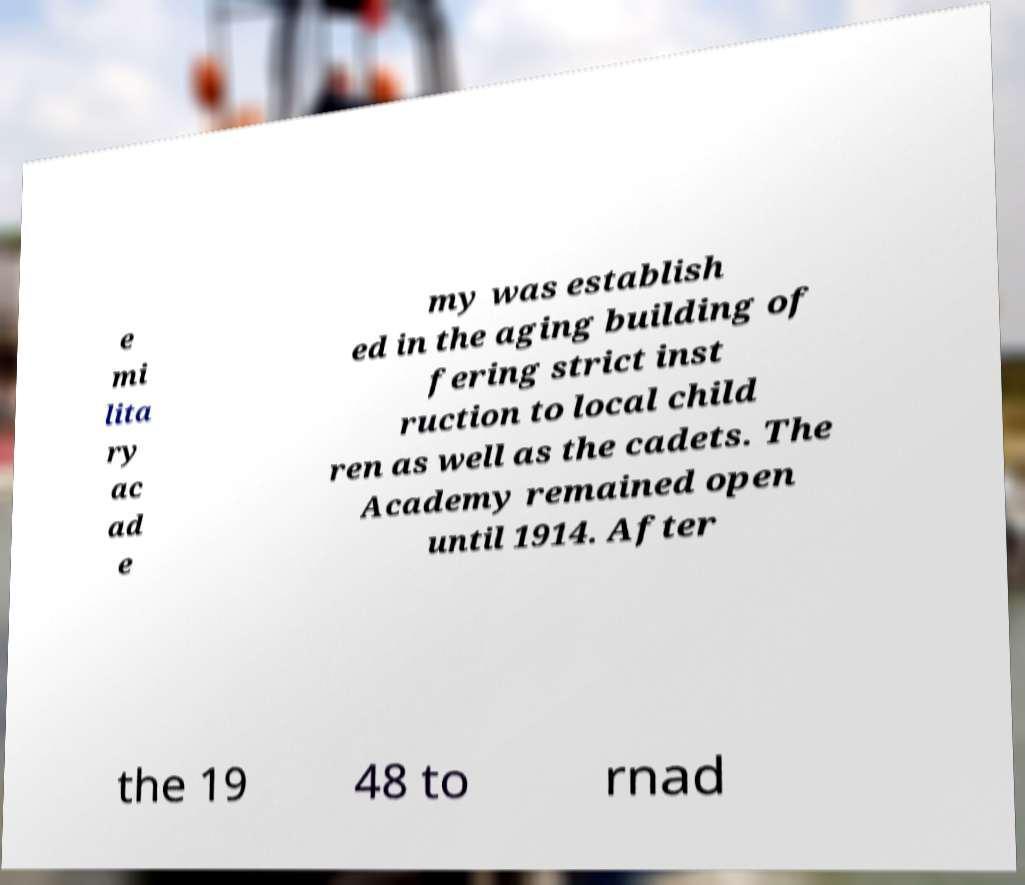Please identify and transcribe the text found in this image. e mi lita ry ac ad e my was establish ed in the aging building of fering strict inst ruction to local child ren as well as the cadets. The Academy remained open until 1914. After the 19 48 to rnad 